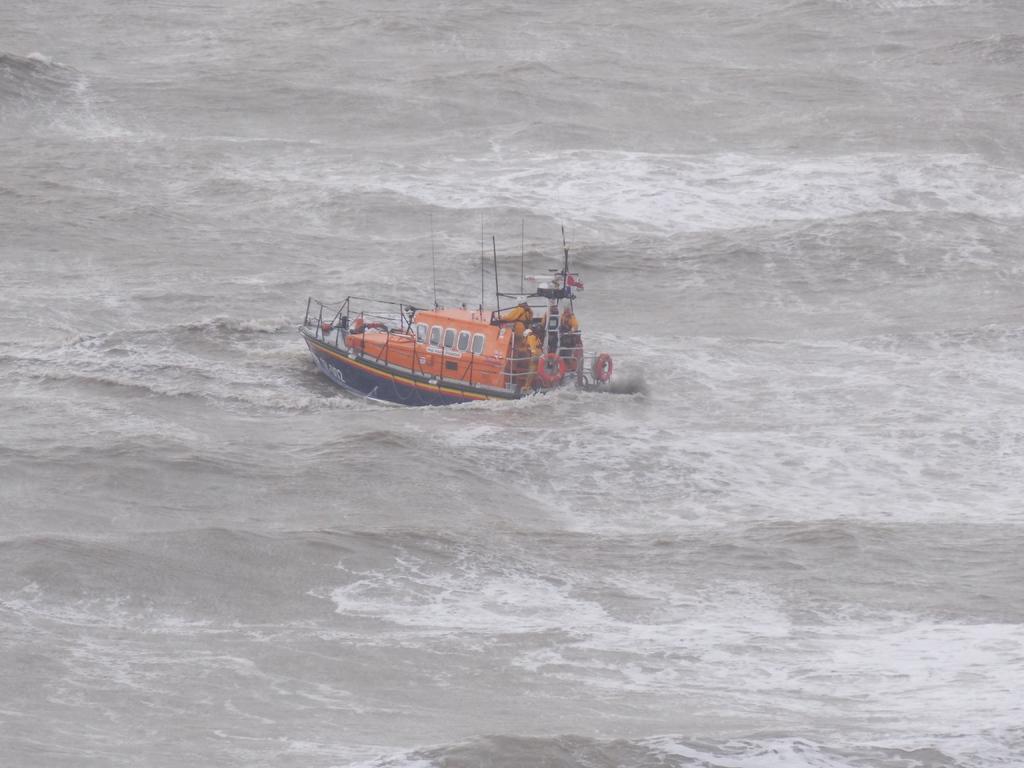Could you give a brief overview of what you see in this image? In the center of the image there is a ship. At the bottom of the image there is water. 